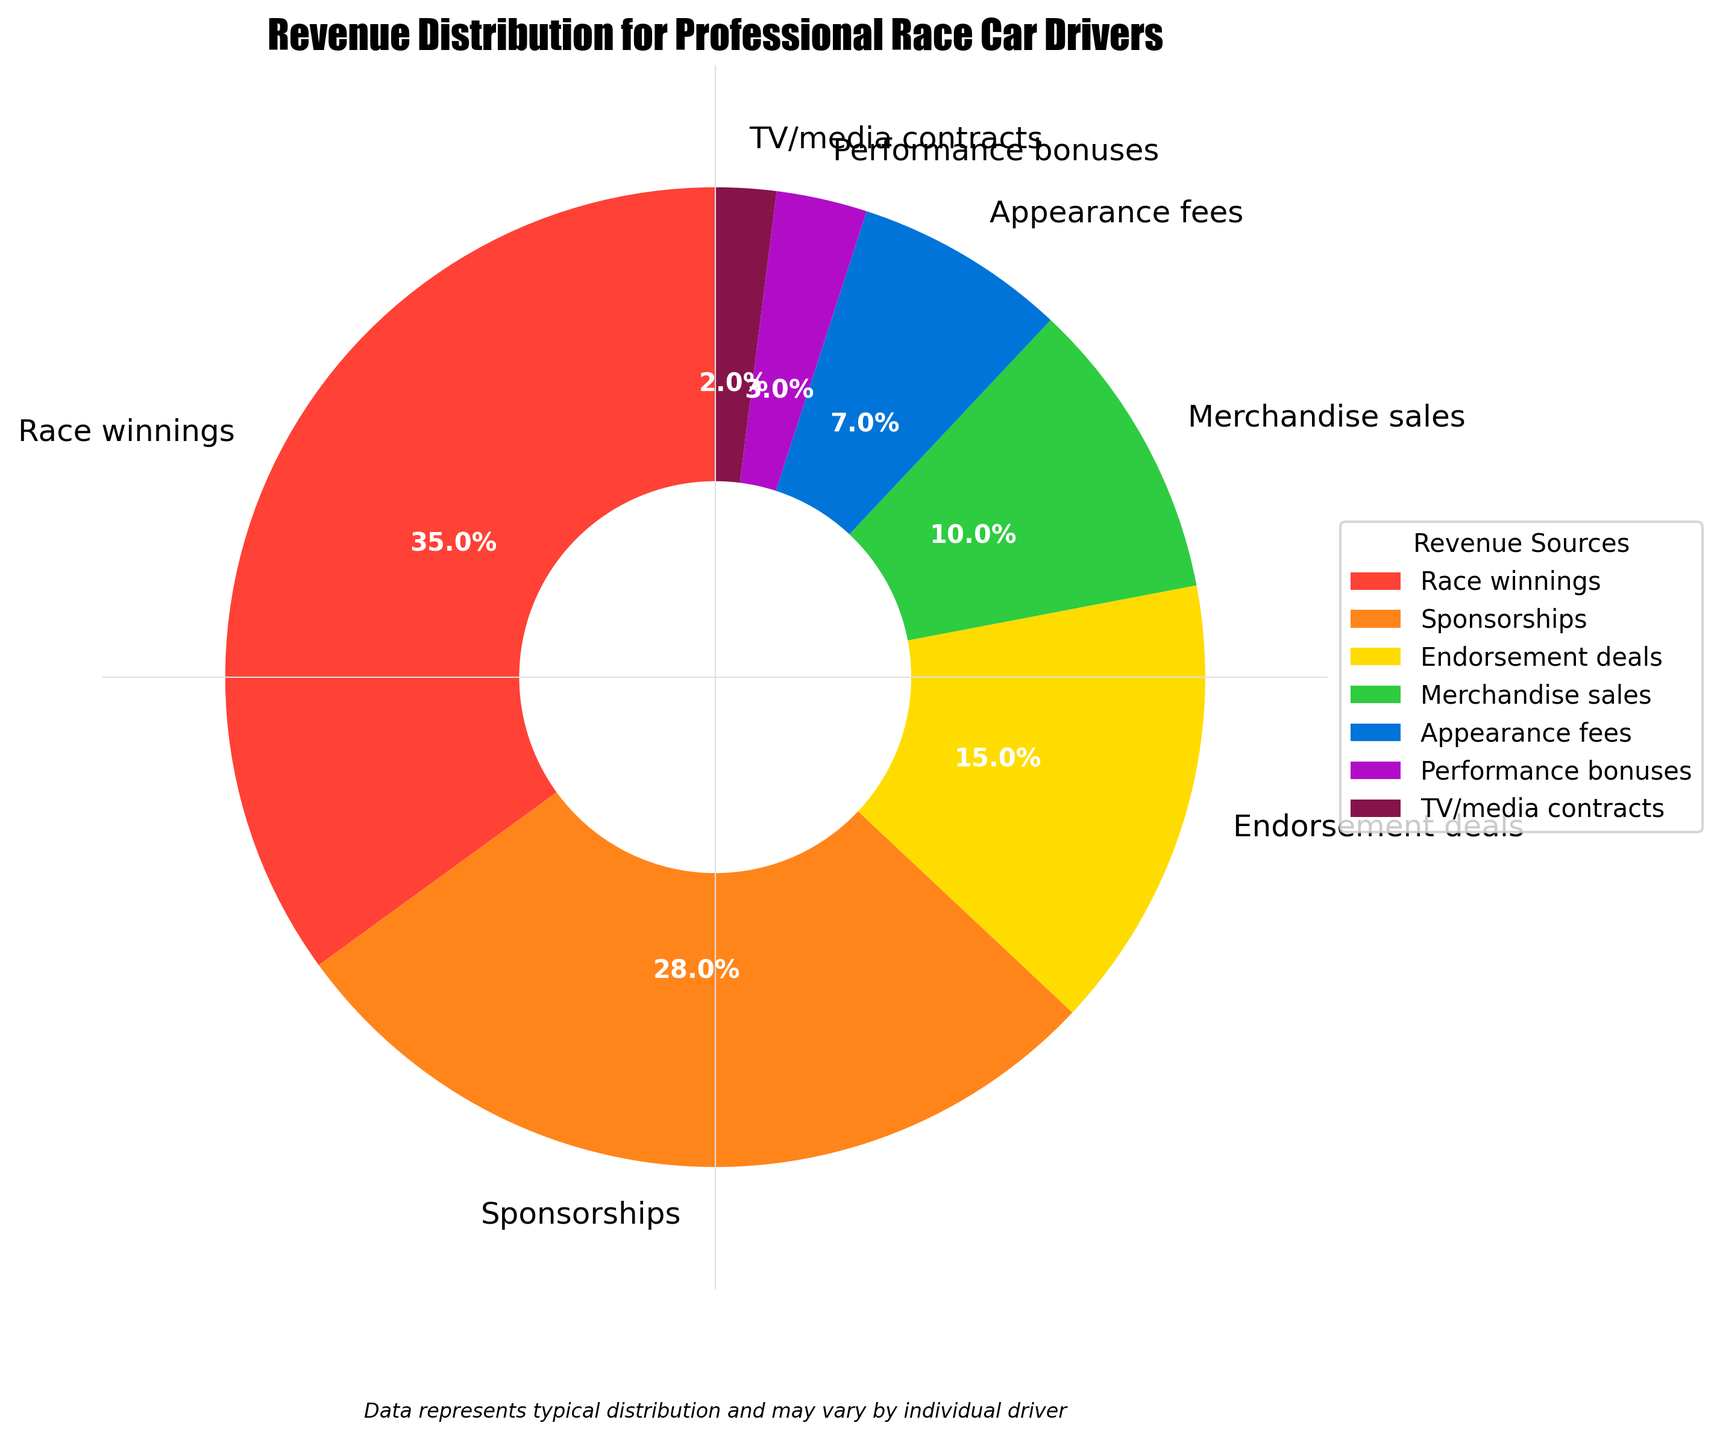What is the largest revenue source for professional race car drivers? The pie chart shows that the largest revenue source is 'Race winnings' with the highest percentage. All the segments' percentages are labeled, and 'Race winnings' holds the highest percentage at 35%
Answer: Race winnings How much more do race winnings contribute compared to performance bonuses? The 'Race winnings' segment provides 35% of the total revenue, while 'Performance bonuses' contribute 3%. The difference can be calculated as 35% - 3% = 32%
Answer: 32% Is the proportion from sponsorships higher than endorsement deals? In the pie chart, 'Sponsorships' contribute 28% of the revenue, and 'Endorsement deals' contribute 15%. Since 28% is greater than 15%, sponsorships have a higher proportion
Answer: Yes Combine the percentages of merchandise sales and appearance fees. What is the total contribution of these two sources? The pie chart shows that 'Merchandise sales' contribute 10% and 'Appearance fees' contribute 7%. Summing these values, we get 10% + 7% = 17%
Answer: 17% Which revenue source has the smallest contribution? By looking at the pie chart, the smallest segment represents 'TV/media contracts,' which contribute 2% to the total revenue
Answer: TV/media contracts What is the combined percentage from race winnings and sponsorships? How does it compare to half of the total revenue? 'Race winnings' contribute 35% and 'Sponsorships' contribute 28%. Adding these percentages, we get 35% + 28% = 63%. Half of the total revenue is 50%, and 63% is greater than 50%
Answer: 63%, greater than 50% Of the sources contributing more than 10%, which one provides the least revenue? Sources contributing more than 10% are 'Race winnings' (35%), 'Sponsorships' (28%), and 'Endorsement deals' (15%). The smallest among these is 'Endorsement deals' at 15%
Answer: Endorsement deals How does the contribution of appearance fees compare to merchandise sales? 'Appearance fees' contribute 7% and 'Merchandise sales' contribute 10%. Since 10% is greater than 7%, merchandise sales have a higher contribution
Answer: Merchandise sales Identify all revenue sources that together make up less than 20% of the total revenue The pie chart shows the percentages for each revenue source. 'Performance bonuses' (3%), 'TV/media contracts' (2%), and 'Appearance fees' (7%) can be added: 3% + 2% + 7% = 12%. Since 12% is less than 20%, these are the sources contributing less than 20%
Answer: Performance bonuses, TV/media contracts, Appearance fees 